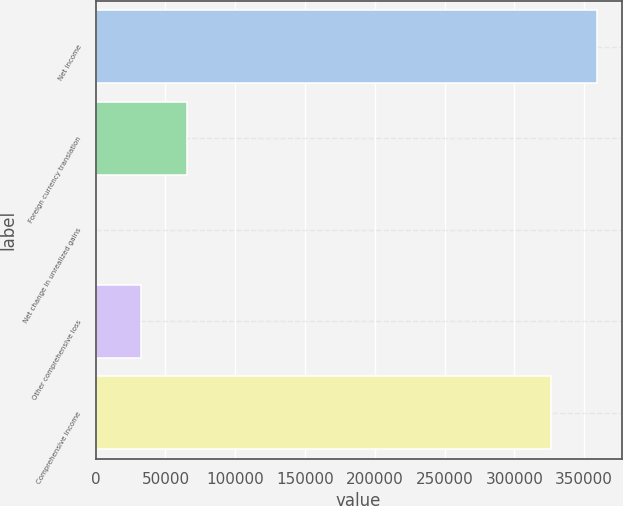<chart> <loc_0><loc_0><loc_500><loc_500><bar_chart><fcel>Net income<fcel>Foreign currency translation<fcel>Net change in unrealized gains<fcel>Other comprehensive loss<fcel>Comprehensive income<nl><fcel>358869<fcel>65633.4<fcel>13<fcel>32823.2<fcel>326059<nl></chart> 